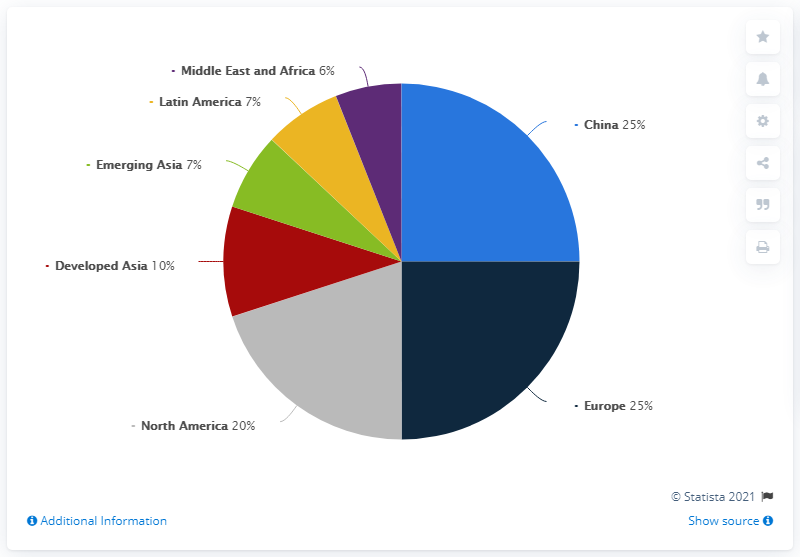Specify some key components in this picture. There are two countries that share a similar goods market. Latin America has a ratio of 1 to Emerging Asia. 